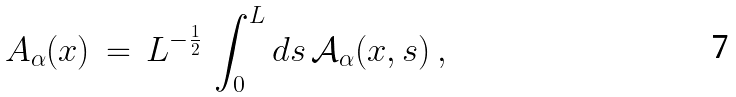Convert formula to latex. <formula><loc_0><loc_0><loc_500><loc_500>A _ { \alpha } ( x ) \, = \, L ^ { - \frac { 1 } { 2 } } \, \int _ { 0 } ^ { L } d s \, { \mathcal { A } } _ { \alpha } ( x , s ) \, ,</formula> 